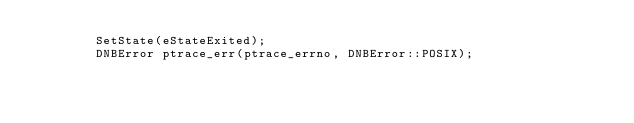<code> <loc_0><loc_0><loc_500><loc_500><_ObjectiveC_>        SetState(eStateExited);
        DNBError ptrace_err(ptrace_errno, DNBError::POSIX);</code> 